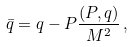<formula> <loc_0><loc_0><loc_500><loc_500>\bar { q } = q - P \frac { ( P , q ) } { M ^ { 2 } } \, ,</formula> 